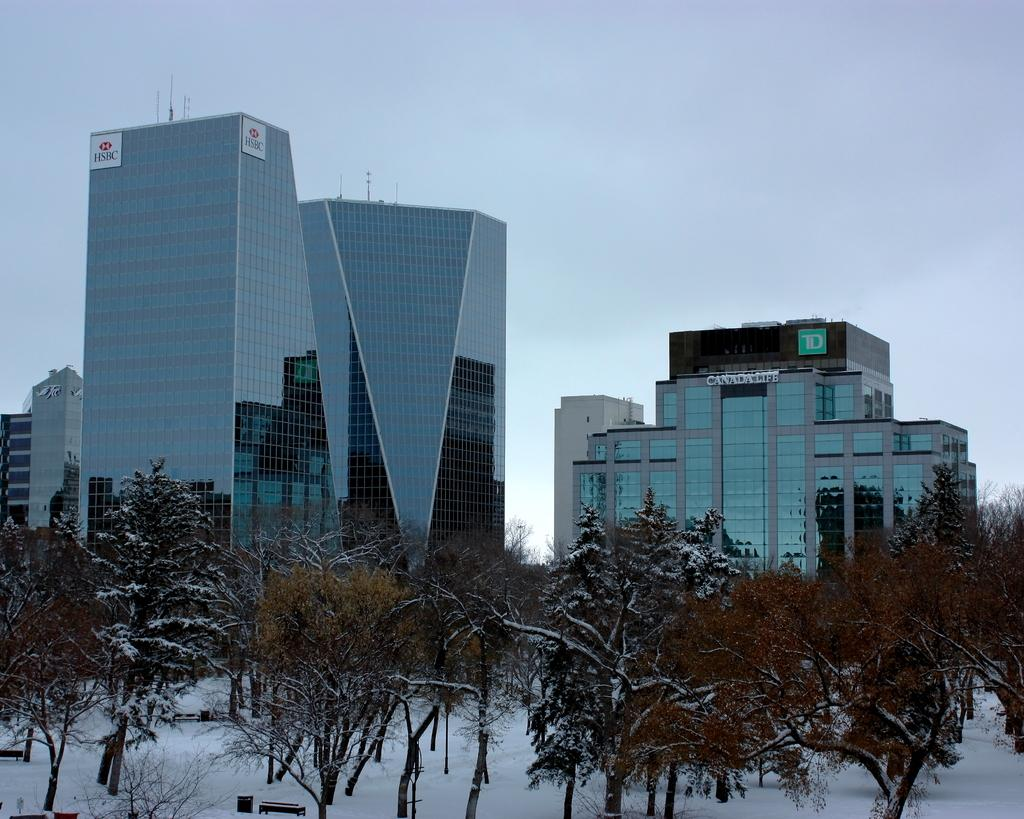What type of structures are present in the image? There are buildings in the image. What is located in front of the buildings? There are trees in front of the buildings. What is the weather like in the image? There is snow visible in the image, indicating a cold or wintery weather. What is visible at the top of the image? The sky is visible at the top of the image. Where is the flame coming from in the image? There is no flame present in the image. What color are the mittens on the trees in the image? There are no mittens present in the image; it features trees without any clothing or accessories. 